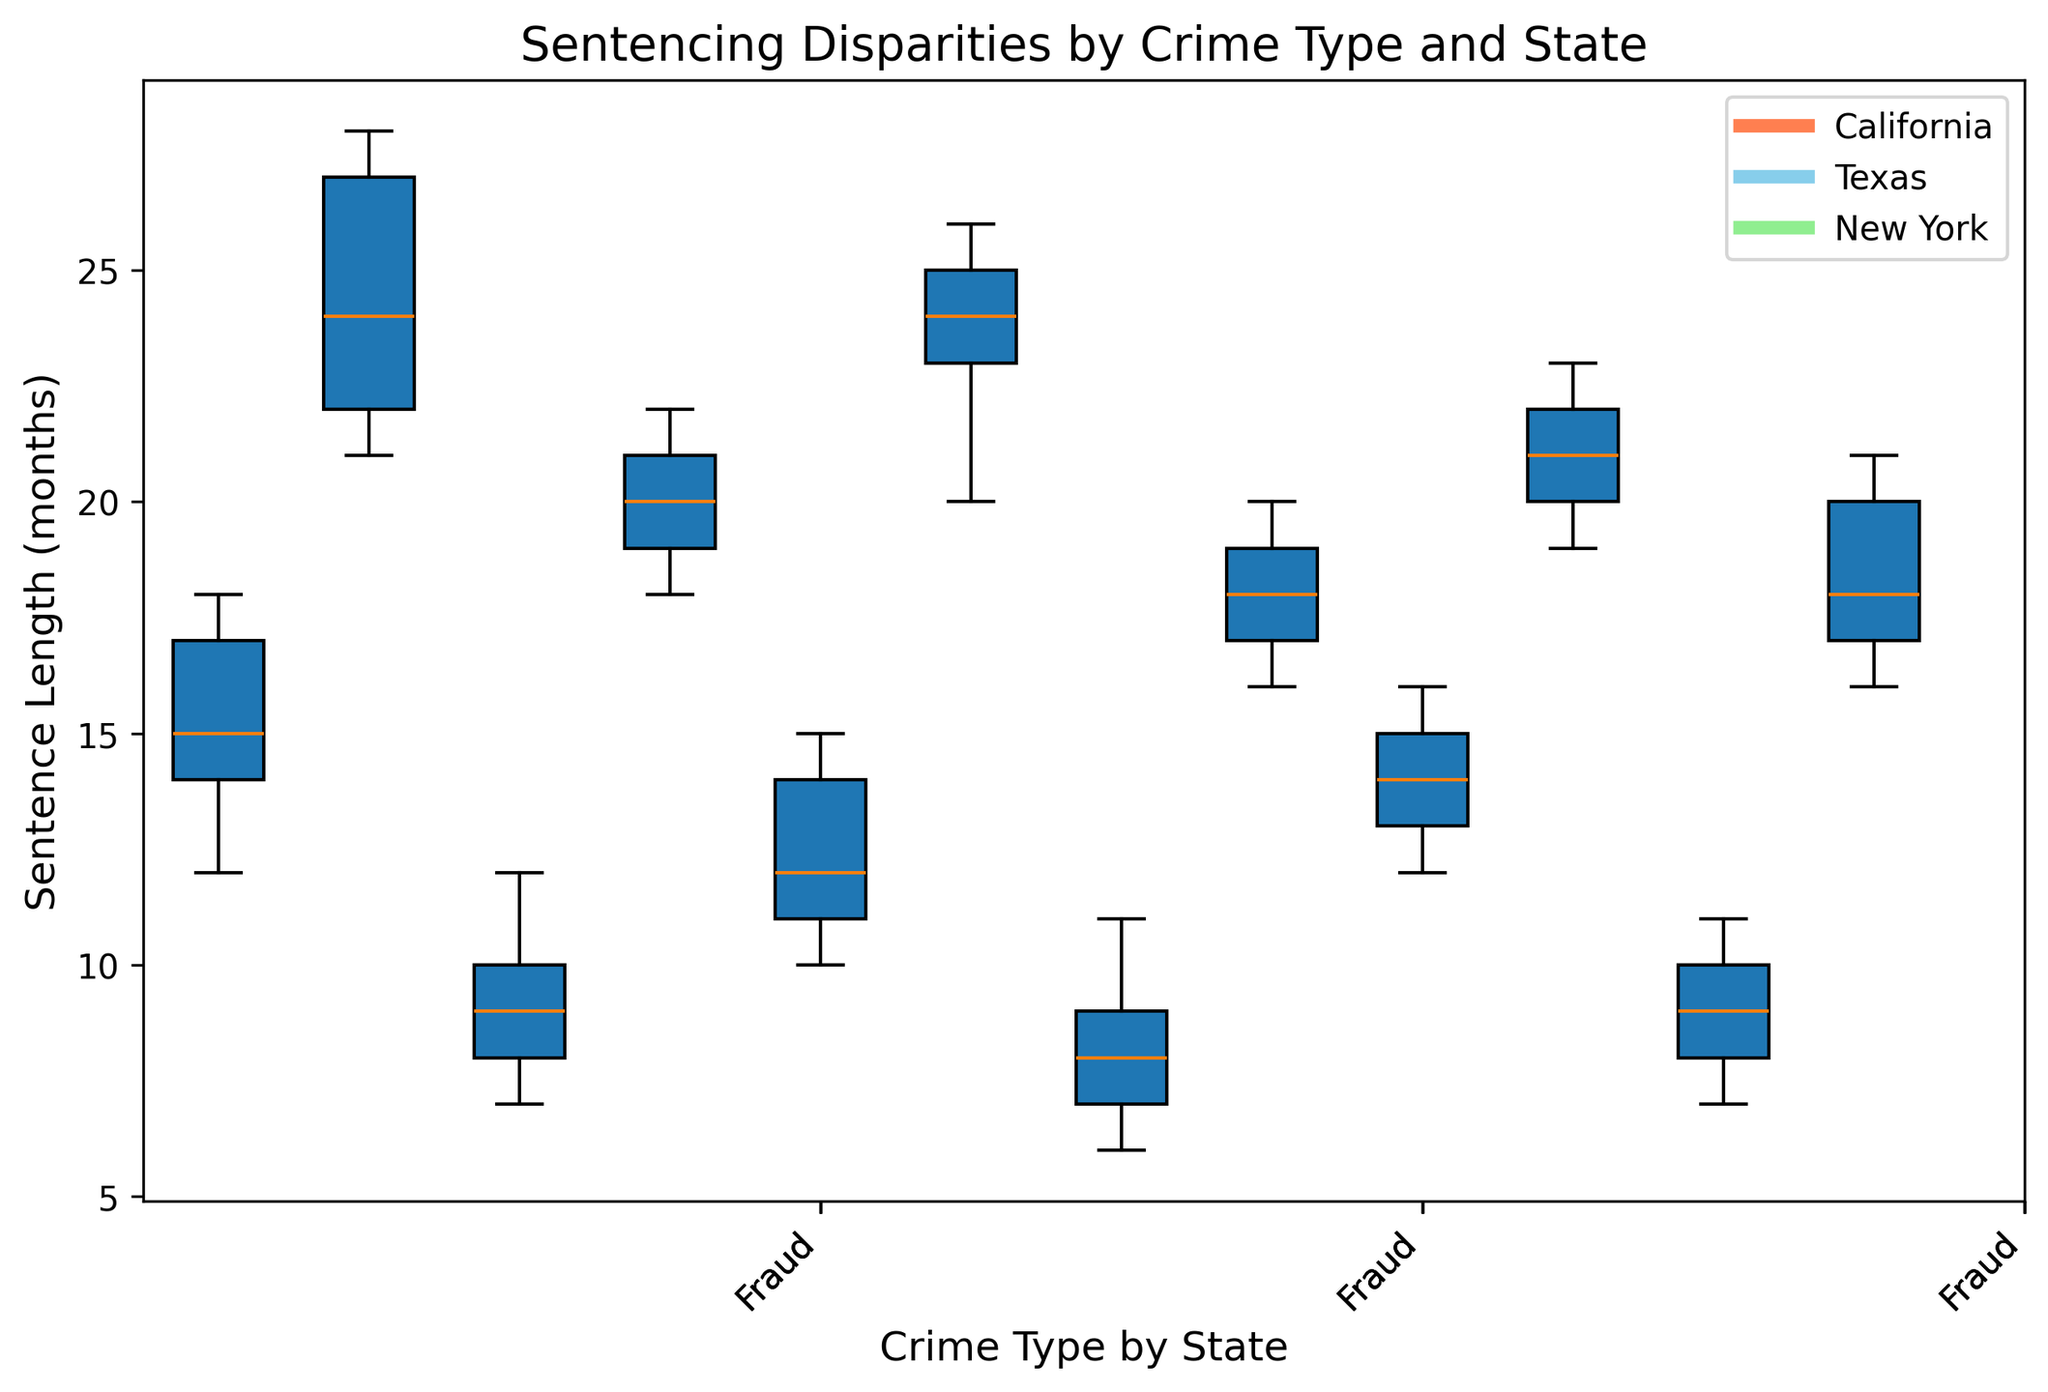What is the median sentence length for theft in California? To find the median, we need to arrange the sentence lengths for theft in California (12, 15, 14, 18, 17) in ascending order: 12, 14, 15, 17, 18. The median, being the middle value, is 15.
Answer: 15 Which state has the lowest median sentence length for assault? Inspecting the box plots for assault across California, Texas, and New York shows that New York has the lowest median among those states.
Answer: New York Which crime type has the widest range of sentence lengths in New York? The range is calculated by the difference between the maximum and minimum values for each crime type's box plot. Comparing the range for each crime type in New York visually, assault stands out with the widest range.
Answer: Assault How does the interquartile range (IQR) for drug possession in Texas compare to that in California? The IQR is the range between the first (Q1) and third quartile (Q3). Visually comparing the box plots for drug possession, California has a slightly wider IQR than Texas.
Answer: California is wider What is the median sentence length for fraud in Texas? To identify the median, look at the box plot for fraud in Texas. The median is visually represented by the line inside the box, which is around 18.
Answer: 18 Which state has the highest variability in sentencing for fraud? Variability can be assessed by the overall spread of the box plot. Texas exhibits the highest variability in its box plot for fraud sentences.
Answer: Texas Are sentences for drug possession generally shorter than those for theft in California? Comparing the box plots for drug possession and theft in California, it can be observed that sentences for drug possession are generally shorter than those for theft.
Answer: Yes Between New York and Texas, which state has a higher median sentence length for theft? The median is depicted by the central line inside the box plot. Comparing both states, New York shows a slightly higher median than Texas for theft.
Answer: New York 